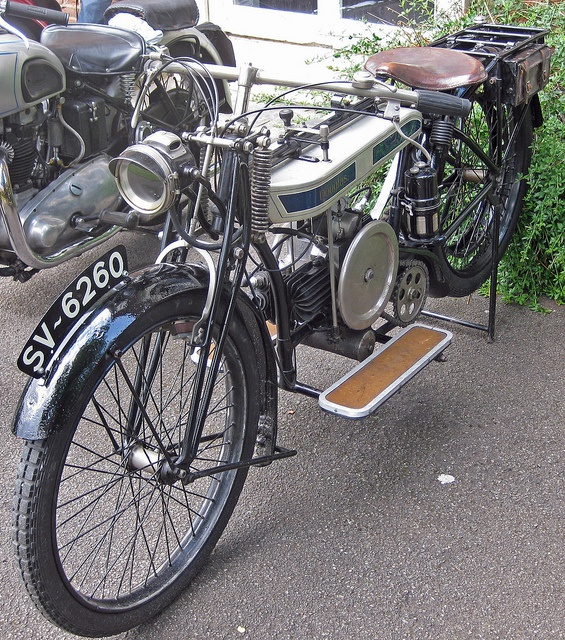Describe the objects in this image and their specific colors. I can see motorcycle in darkgray, black, gray, and lightgray tones and motorcycle in darkgray, gray, black, and white tones in this image. 